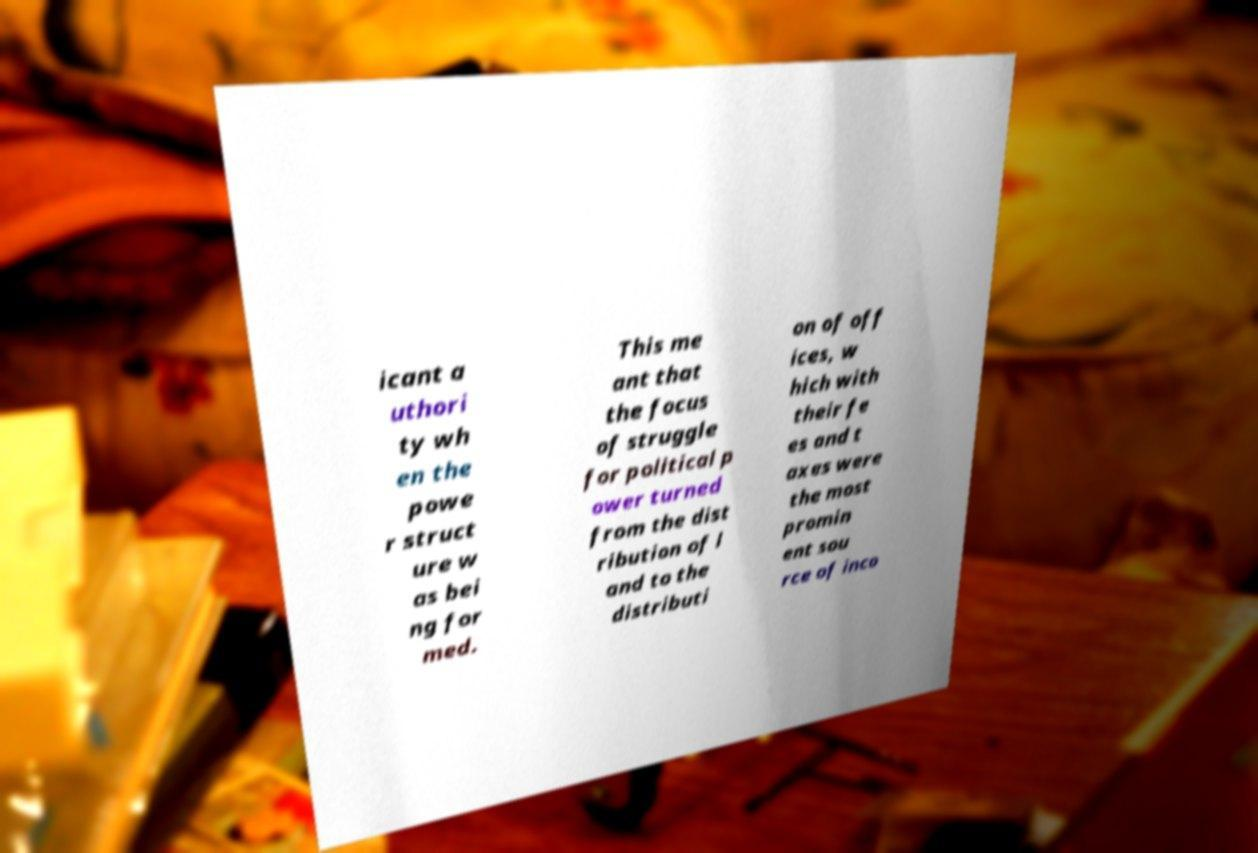Please read and relay the text visible in this image. What does it say? icant a uthori ty wh en the powe r struct ure w as bei ng for med. This me ant that the focus of struggle for political p ower turned from the dist ribution of l and to the distributi on of off ices, w hich with their fe es and t axes were the most promin ent sou rce of inco 